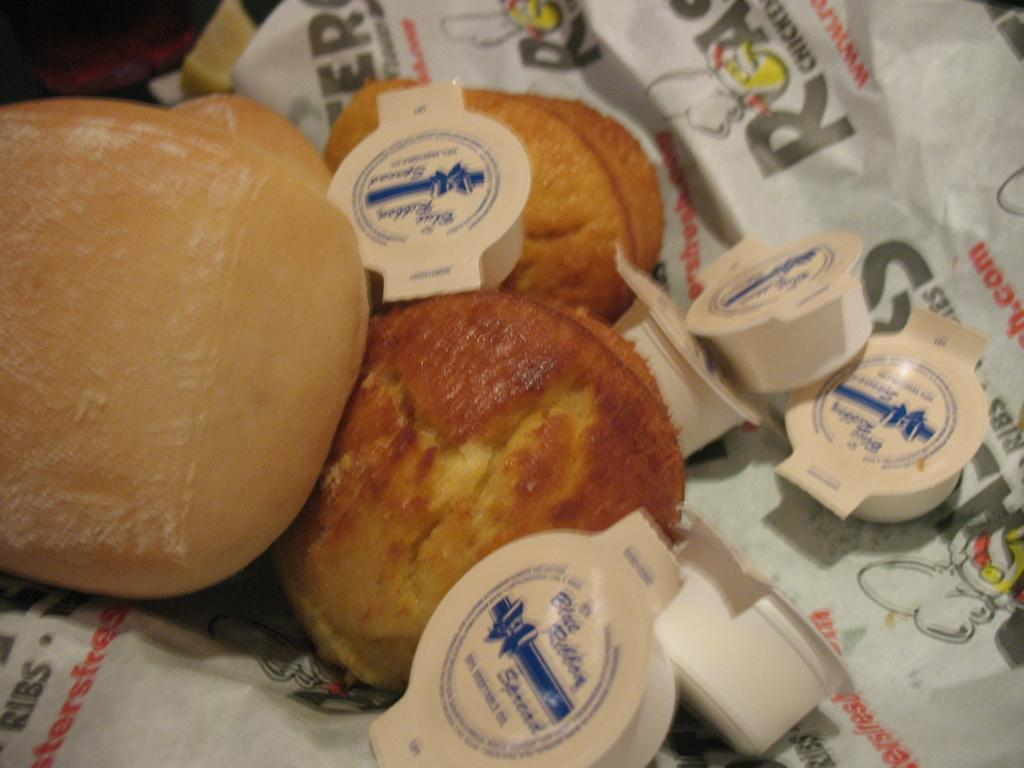What type of food can be seen in the image? There are cakes in the image. How are the cakes wrapped or presented? The cakes are in white color paper. What else can be seen in the image besides the cakes? There are cups in the image. How are the cups presented or wrapped? The cups are in white color paper. Are there any pigs visible in the image? No, there are no pigs present in the image. Can you see a ghost interacting with the cakes in the image? No, there is no ghost present in the image. 